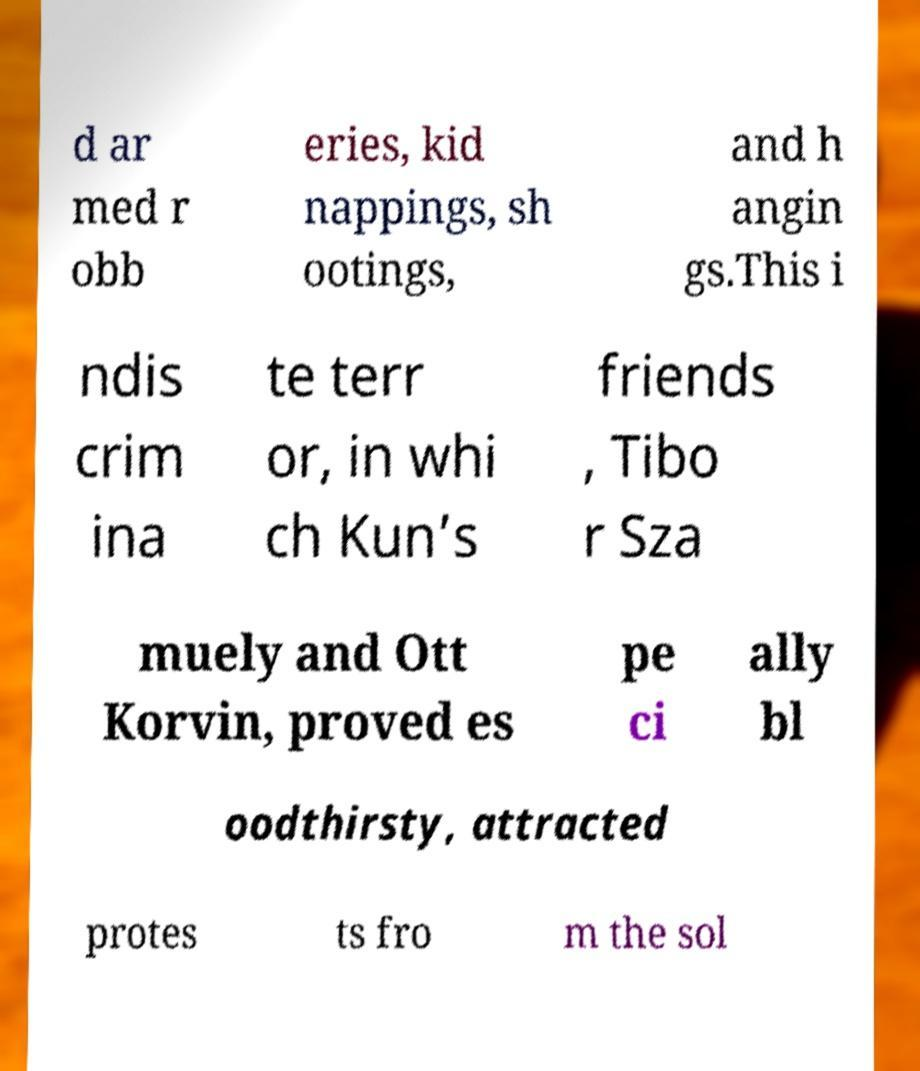Can you read and provide the text displayed in the image?This photo seems to have some interesting text. Can you extract and type it out for me? d ar med r obb eries, kid nappings, sh ootings, and h angin gs.This i ndis crim ina te terr or, in whi ch Kun’s friends , Tibo r Sza muely and Ott Korvin, proved es pe ci ally bl oodthirsty, attracted protes ts fro m the sol 